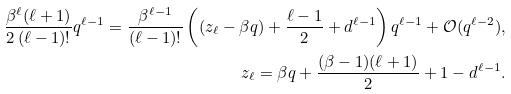<formula> <loc_0><loc_0><loc_500><loc_500>\frac { \beta ^ { \ell } ( \ell + 1 ) } { 2 \, ( \ell - 1 ) ! } q ^ { \ell - 1 } = \frac { \beta ^ { \ell - 1 } } { ( \ell - 1 ) ! } \left ( ( z _ { \ell } - \beta q ) + \frac { \ell - 1 } 2 + d ^ { \ell - 1 } \right ) q ^ { \ell - 1 } + \mathcal { O } ( q ^ { \ell - 2 } ) , \\ z _ { \ell } = \beta q + \frac { ( \beta - 1 ) ( \ell + 1 ) } 2 + 1 - d ^ { \ell - 1 } .</formula> 